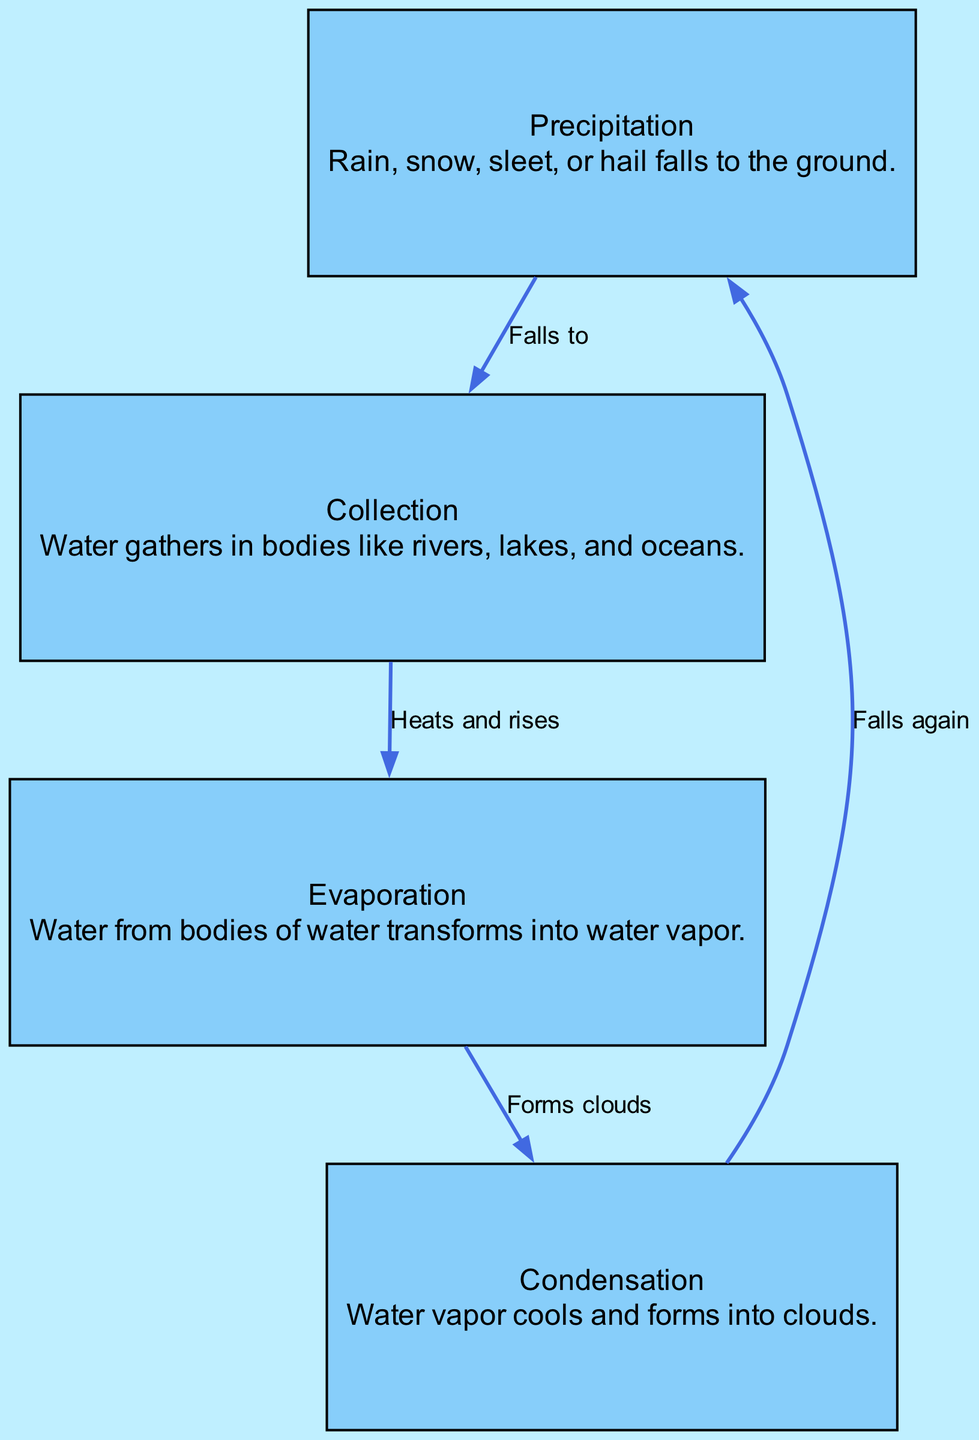What is the first step in the water cycle? The first step in the water cycle as shown in the diagram is "Precipitation," indicating that water falls to the ground as rain, snow, sleet, or hail.
Answer: Precipitation How many nodes are there in this diagram? The diagram contains four nodes representing different stages of the water cycle: Precipitation, Collection, Evaporation, and Condensation. Thus, the total count is 4.
Answer: 4 What does condensation form? According to the diagram, condensation occurs when water vapor cools and forms clouds, showing this process's crucial role in the water cycle.
Answer: Clouds Which process occurs after collection? The diagram indicates that after water collects in bodies like rivers and lakes, it undergoes "Evaporation," where the water heats and rises.
Answer: Evaporation What type of relationship exists between evaporation and condensation? The relationship is described in the diagram as "Forms clouds," indicating that evaporation leads to the formation of clouds through condensation of the water vapor.
Answer: Forms clouds What action does precipitation lead to in the water cycle? The diagram shows that precipitation leads to "Collection," where the fallen water gathers in bodies of water.
Answer: Collection Which two nodes are connected by the label "Falls again"? In the diagram, the label "Falls again" connects the nodes "Condensation" and "Precipitation," indicating that once condensation occurs, it results in precipitation falling.
Answer: Condensation and Precipitation What is the last step before precipitation? Referring to the diagram, the last step before precipitation is "Condensation," where water vapor cools to form clouds that will eventually lead to precipitation.
Answer: Condensation What does the label "Heats and rises" indicate? The label "Heats and rises" indicates the process of evaporation, signifying that after collection, the water heats up and transforms into vapor.
Answer: Heats and rises 